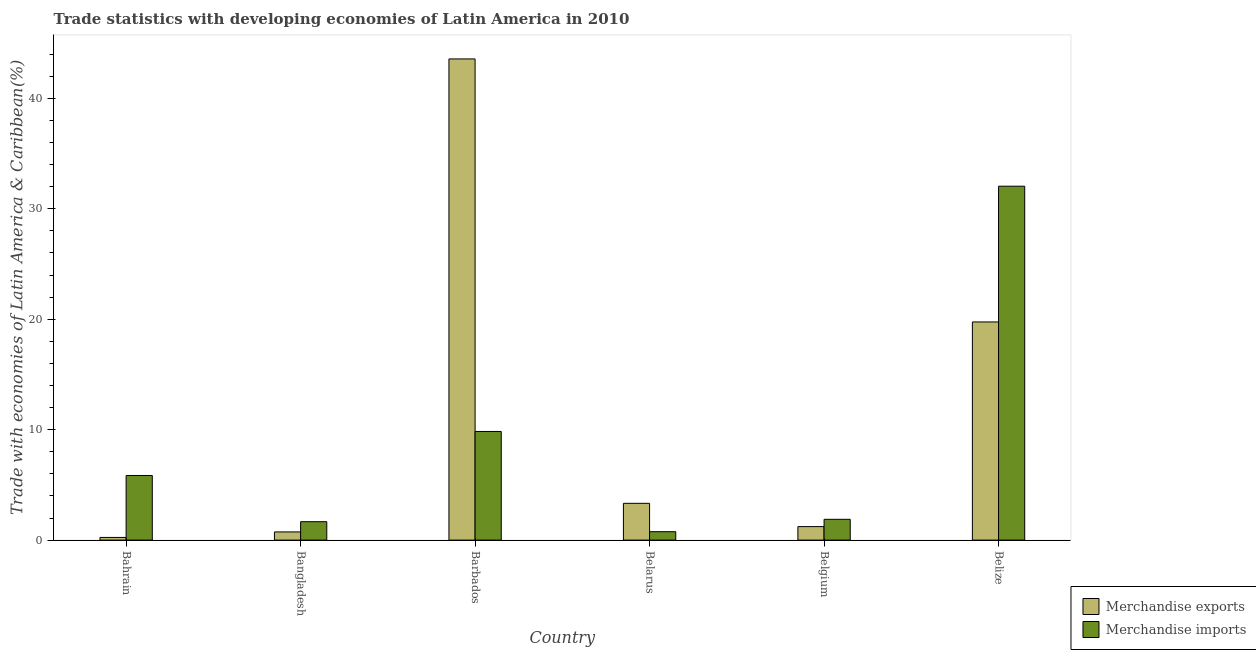Are the number of bars per tick equal to the number of legend labels?
Provide a succinct answer. Yes. How many bars are there on the 1st tick from the left?
Provide a short and direct response. 2. What is the label of the 1st group of bars from the left?
Give a very brief answer. Bahrain. In how many cases, is the number of bars for a given country not equal to the number of legend labels?
Offer a very short reply. 0. What is the merchandise exports in Belize?
Make the answer very short. 19.75. Across all countries, what is the maximum merchandise imports?
Make the answer very short. 32.05. Across all countries, what is the minimum merchandise imports?
Provide a succinct answer. 0.76. In which country was the merchandise exports maximum?
Provide a short and direct response. Barbados. In which country was the merchandise exports minimum?
Your response must be concise. Bahrain. What is the total merchandise imports in the graph?
Your response must be concise. 52.04. What is the difference between the merchandise imports in Bangladesh and that in Belize?
Keep it short and to the point. -30.38. What is the difference between the merchandise exports in Belgium and the merchandise imports in Barbados?
Offer a very short reply. -8.61. What is the average merchandise imports per country?
Your answer should be very brief. 8.67. What is the difference between the merchandise imports and merchandise exports in Belarus?
Your response must be concise. -2.57. What is the ratio of the merchandise exports in Bangladesh to that in Belarus?
Your response must be concise. 0.22. What is the difference between the highest and the second highest merchandise exports?
Offer a terse response. 23.82. What is the difference between the highest and the lowest merchandise imports?
Provide a short and direct response. 31.28. Is the sum of the merchandise exports in Belarus and Belize greater than the maximum merchandise imports across all countries?
Provide a short and direct response. No. What does the 1st bar from the left in Bangladesh represents?
Your answer should be compact. Merchandise exports. What does the 1st bar from the right in Barbados represents?
Your answer should be very brief. Merchandise imports. Are the values on the major ticks of Y-axis written in scientific E-notation?
Your response must be concise. No. Does the graph contain any zero values?
Give a very brief answer. No. How many legend labels are there?
Ensure brevity in your answer.  2. What is the title of the graph?
Provide a short and direct response. Trade statistics with developing economies of Latin America in 2010. Does "Exports" appear as one of the legend labels in the graph?
Your answer should be compact. No. What is the label or title of the Y-axis?
Ensure brevity in your answer.  Trade with economies of Latin America & Caribbean(%). What is the Trade with economies of Latin America & Caribbean(%) of Merchandise exports in Bahrain?
Offer a very short reply. 0.24. What is the Trade with economies of Latin America & Caribbean(%) in Merchandise imports in Bahrain?
Make the answer very short. 5.85. What is the Trade with economies of Latin America & Caribbean(%) of Merchandise exports in Bangladesh?
Keep it short and to the point. 0.74. What is the Trade with economies of Latin America & Caribbean(%) of Merchandise imports in Bangladesh?
Offer a terse response. 1.67. What is the Trade with economies of Latin America & Caribbean(%) of Merchandise exports in Barbados?
Offer a terse response. 43.57. What is the Trade with economies of Latin America & Caribbean(%) of Merchandise imports in Barbados?
Keep it short and to the point. 9.84. What is the Trade with economies of Latin America & Caribbean(%) in Merchandise exports in Belarus?
Provide a short and direct response. 3.33. What is the Trade with economies of Latin America & Caribbean(%) of Merchandise imports in Belarus?
Offer a very short reply. 0.76. What is the Trade with economies of Latin America & Caribbean(%) of Merchandise exports in Belgium?
Give a very brief answer. 1.22. What is the Trade with economies of Latin America & Caribbean(%) of Merchandise imports in Belgium?
Make the answer very short. 1.88. What is the Trade with economies of Latin America & Caribbean(%) of Merchandise exports in Belize?
Give a very brief answer. 19.75. What is the Trade with economies of Latin America & Caribbean(%) of Merchandise imports in Belize?
Offer a terse response. 32.05. Across all countries, what is the maximum Trade with economies of Latin America & Caribbean(%) in Merchandise exports?
Make the answer very short. 43.57. Across all countries, what is the maximum Trade with economies of Latin America & Caribbean(%) of Merchandise imports?
Ensure brevity in your answer.  32.05. Across all countries, what is the minimum Trade with economies of Latin America & Caribbean(%) in Merchandise exports?
Keep it short and to the point. 0.24. Across all countries, what is the minimum Trade with economies of Latin America & Caribbean(%) of Merchandise imports?
Keep it short and to the point. 0.76. What is the total Trade with economies of Latin America & Caribbean(%) of Merchandise exports in the graph?
Your answer should be very brief. 68.86. What is the total Trade with economies of Latin America & Caribbean(%) of Merchandise imports in the graph?
Your answer should be compact. 52.04. What is the difference between the Trade with economies of Latin America & Caribbean(%) of Merchandise exports in Bahrain and that in Bangladesh?
Ensure brevity in your answer.  -0.5. What is the difference between the Trade with economies of Latin America & Caribbean(%) of Merchandise imports in Bahrain and that in Bangladesh?
Ensure brevity in your answer.  4.18. What is the difference between the Trade with economies of Latin America & Caribbean(%) of Merchandise exports in Bahrain and that in Barbados?
Offer a very short reply. -43.33. What is the difference between the Trade with economies of Latin America & Caribbean(%) in Merchandise imports in Bahrain and that in Barbados?
Your answer should be very brief. -3.99. What is the difference between the Trade with economies of Latin America & Caribbean(%) in Merchandise exports in Bahrain and that in Belarus?
Provide a short and direct response. -3.09. What is the difference between the Trade with economies of Latin America & Caribbean(%) in Merchandise imports in Bahrain and that in Belarus?
Your response must be concise. 5.09. What is the difference between the Trade with economies of Latin America & Caribbean(%) of Merchandise exports in Bahrain and that in Belgium?
Offer a very short reply. -0.98. What is the difference between the Trade with economies of Latin America & Caribbean(%) of Merchandise imports in Bahrain and that in Belgium?
Your answer should be very brief. 3.97. What is the difference between the Trade with economies of Latin America & Caribbean(%) in Merchandise exports in Bahrain and that in Belize?
Your response must be concise. -19.51. What is the difference between the Trade with economies of Latin America & Caribbean(%) in Merchandise imports in Bahrain and that in Belize?
Provide a succinct answer. -26.19. What is the difference between the Trade with economies of Latin America & Caribbean(%) of Merchandise exports in Bangladesh and that in Barbados?
Your answer should be compact. -42.83. What is the difference between the Trade with economies of Latin America & Caribbean(%) in Merchandise imports in Bangladesh and that in Barbados?
Offer a terse response. -8.17. What is the difference between the Trade with economies of Latin America & Caribbean(%) of Merchandise exports in Bangladesh and that in Belarus?
Provide a succinct answer. -2.59. What is the difference between the Trade with economies of Latin America & Caribbean(%) of Merchandise imports in Bangladesh and that in Belarus?
Your answer should be compact. 0.9. What is the difference between the Trade with economies of Latin America & Caribbean(%) of Merchandise exports in Bangladesh and that in Belgium?
Make the answer very short. -0.48. What is the difference between the Trade with economies of Latin America & Caribbean(%) of Merchandise imports in Bangladesh and that in Belgium?
Provide a succinct answer. -0.22. What is the difference between the Trade with economies of Latin America & Caribbean(%) of Merchandise exports in Bangladesh and that in Belize?
Ensure brevity in your answer.  -19.01. What is the difference between the Trade with economies of Latin America & Caribbean(%) in Merchandise imports in Bangladesh and that in Belize?
Keep it short and to the point. -30.38. What is the difference between the Trade with economies of Latin America & Caribbean(%) in Merchandise exports in Barbados and that in Belarus?
Ensure brevity in your answer.  40.24. What is the difference between the Trade with economies of Latin America & Caribbean(%) in Merchandise imports in Barbados and that in Belarus?
Make the answer very short. 9.08. What is the difference between the Trade with economies of Latin America & Caribbean(%) in Merchandise exports in Barbados and that in Belgium?
Offer a terse response. 42.35. What is the difference between the Trade with economies of Latin America & Caribbean(%) in Merchandise imports in Barbados and that in Belgium?
Keep it short and to the point. 7.95. What is the difference between the Trade with economies of Latin America & Caribbean(%) of Merchandise exports in Barbados and that in Belize?
Provide a succinct answer. 23.82. What is the difference between the Trade with economies of Latin America & Caribbean(%) in Merchandise imports in Barbados and that in Belize?
Give a very brief answer. -22.21. What is the difference between the Trade with economies of Latin America & Caribbean(%) of Merchandise exports in Belarus and that in Belgium?
Provide a short and direct response. 2.11. What is the difference between the Trade with economies of Latin America & Caribbean(%) of Merchandise imports in Belarus and that in Belgium?
Provide a short and direct response. -1.12. What is the difference between the Trade with economies of Latin America & Caribbean(%) of Merchandise exports in Belarus and that in Belize?
Make the answer very short. -16.42. What is the difference between the Trade with economies of Latin America & Caribbean(%) in Merchandise imports in Belarus and that in Belize?
Ensure brevity in your answer.  -31.28. What is the difference between the Trade with economies of Latin America & Caribbean(%) of Merchandise exports in Belgium and that in Belize?
Provide a short and direct response. -18.53. What is the difference between the Trade with economies of Latin America & Caribbean(%) in Merchandise imports in Belgium and that in Belize?
Your answer should be compact. -30.16. What is the difference between the Trade with economies of Latin America & Caribbean(%) of Merchandise exports in Bahrain and the Trade with economies of Latin America & Caribbean(%) of Merchandise imports in Bangladesh?
Provide a short and direct response. -1.42. What is the difference between the Trade with economies of Latin America & Caribbean(%) of Merchandise exports in Bahrain and the Trade with economies of Latin America & Caribbean(%) of Merchandise imports in Barbados?
Provide a short and direct response. -9.6. What is the difference between the Trade with economies of Latin America & Caribbean(%) in Merchandise exports in Bahrain and the Trade with economies of Latin America & Caribbean(%) in Merchandise imports in Belarus?
Offer a terse response. -0.52. What is the difference between the Trade with economies of Latin America & Caribbean(%) of Merchandise exports in Bahrain and the Trade with economies of Latin America & Caribbean(%) of Merchandise imports in Belgium?
Offer a very short reply. -1.64. What is the difference between the Trade with economies of Latin America & Caribbean(%) in Merchandise exports in Bahrain and the Trade with economies of Latin America & Caribbean(%) in Merchandise imports in Belize?
Your response must be concise. -31.8. What is the difference between the Trade with economies of Latin America & Caribbean(%) of Merchandise exports in Bangladesh and the Trade with economies of Latin America & Caribbean(%) of Merchandise imports in Barbados?
Offer a very short reply. -9.1. What is the difference between the Trade with economies of Latin America & Caribbean(%) of Merchandise exports in Bangladesh and the Trade with economies of Latin America & Caribbean(%) of Merchandise imports in Belarus?
Offer a very short reply. -0.02. What is the difference between the Trade with economies of Latin America & Caribbean(%) in Merchandise exports in Bangladesh and the Trade with economies of Latin America & Caribbean(%) in Merchandise imports in Belgium?
Make the answer very short. -1.14. What is the difference between the Trade with economies of Latin America & Caribbean(%) in Merchandise exports in Bangladesh and the Trade with economies of Latin America & Caribbean(%) in Merchandise imports in Belize?
Keep it short and to the point. -31.31. What is the difference between the Trade with economies of Latin America & Caribbean(%) of Merchandise exports in Barbados and the Trade with economies of Latin America & Caribbean(%) of Merchandise imports in Belarus?
Your answer should be compact. 42.81. What is the difference between the Trade with economies of Latin America & Caribbean(%) of Merchandise exports in Barbados and the Trade with economies of Latin America & Caribbean(%) of Merchandise imports in Belgium?
Your answer should be compact. 41.69. What is the difference between the Trade with economies of Latin America & Caribbean(%) of Merchandise exports in Barbados and the Trade with economies of Latin America & Caribbean(%) of Merchandise imports in Belize?
Your answer should be compact. 11.52. What is the difference between the Trade with economies of Latin America & Caribbean(%) in Merchandise exports in Belarus and the Trade with economies of Latin America & Caribbean(%) in Merchandise imports in Belgium?
Your answer should be very brief. 1.45. What is the difference between the Trade with economies of Latin America & Caribbean(%) in Merchandise exports in Belarus and the Trade with economies of Latin America & Caribbean(%) in Merchandise imports in Belize?
Offer a very short reply. -28.71. What is the difference between the Trade with economies of Latin America & Caribbean(%) of Merchandise exports in Belgium and the Trade with economies of Latin America & Caribbean(%) of Merchandise imports in Belize?
Give a very brief answer. -30.82. What is the average Trade with economies of Latin America & Caribbean(%) of Merchandise exports per country?
Offer a terse response. 11.48. What is the average Trade with economies of Latin America & Caribbean(%) in Merchandise imports per country?
Your answer should be very brief. 8.67. What is the difference between the Trade with economies of Latin America & Caribbean(%) in Merchandise exports and Trade with economies of Latin America & Caribbean(%) in Merchandise imports in Bahrain?
Keep it short and to the point. -5.61. What is the difference between the Trade with economies of Latin America & Caribbean(%) in Merchandise exports and Trade with economies of Latin America & Caribbean(%) in Merchandise imports in Bangladesh?
Ensure brevity in your answer.  -0.93. What is the difference between the Trade with economies of Latin America & Caribbean(%) of Merchandise exports and Trade with economies of Latin America & Caribbean(%) of Merchandise imports in Barbados?
Keep it short and to the point. 33.73. What is the difference between the Trade with economies of Latin America & Caribbean(%) in Merchandise exports and Trade with economies of Latin America & Caribbean(%) in Merchandise imports in Belarus?
Your response must be concise. 2.57. What is the difference between the Trade with economies of Latin America & Caribbean(%) in Merchandise exports and Trade with economies of Latin America & Caribbean(%) in Merchandise imports in Belgium?
Ensure brevity in your answer.  -0.66. What is the difference between the Trade with economies of Latin America & Caribbean(%) of Merchandise exports and Trade with economies of Latin America & Caribbean(%) of Merchandise imports in Belize?
Your response must be concise. -12.29. What is the ratio of the Trade with economies of Latin America & Caribbean(%) in Merchandise exports in Bahrain to that in Bangladesh?
Offer a terse response. 0.33. What is the ratio of the Trade with economies of Latin America & Caribbean(%) of Merchandise imports in Bahrain to that in Bangladesh?
Make the answer very short. 3.51. What is the ratio of the Trade with economies of Latin America & Caribbean(%) in Merchandise exports in Bahrain to that in Barbados?
Provide a short and direct response. 0.01. What is the ratio of the Trade with economies of Latin America & Caribbean(%) of Merchandise imports in Bahrain to that in Barbados?
Provide a short and direct response. 0.59. What is the ratio of the Trade with economies of Latin America & Caribbean(%) in Merchandise exports in Bahrain to that in Belarus?
Your response must be concise. 0.07. What is the ratio of the Trade with economies of Latin America & Caribbean(%) in Merchandise imports in Bahrain to that in Belarus?
Your answer should be compact. 7.68. What is the ratio of the Trade with economies of Latin America & Caribbean(%) of Merchandise exports in Bahrain to that in Belgium?
Your response must be concise. 0.2. What is the ratio of the Trade with economies of Latin America & Caribbean(%) of Merchandise imports in Bahrain to that in Belgium?
Offer a terse response. 3.11. What is the ratio of the Trade with economies of Latin America & Caribbean(%) in Merchandise exports in Bahrain to that in Belize?
Ensure brevity in your answer.  0.01. What is the ratio of the Trade with economies of Latin America & Caribbean(%) of Merchandise imports in Bahrain to that in Belize?
Provide a short and direct response. 0.18. What is the ratio of the Trade with economies of Latin America & Caribbean(%) of Merchandise exports in Bangladesh to that in Barbados?
Ensure brevity in your answer.  0.02. What is the ratio of the Trade with economies of Latin America & Caribbean(%) of Merchandise imports in Bangladesh to that in Barbados?
Offer a very short reply. 0.17. What is the ratio of the Trade with economies of Latin America & Caribbean(%) in Merchandise exports in Bangladesh to that in Belarus?
Ensure brevity in your answer.  0.22. What is the ratio of the Trade with economies of Latin America & Caribbean(%) in Merchandise imports in Bangladesh to that in Belarus?
Give a very brief answer. 2.19. What is the ratio of the Trade with economies of Latin America & Caribbean(%) in Merchandise exports in Bangladesh to that in Belgium?
Your answer should be very brief. 0.61. What is the ratio of the Trade with economies of Latin America & Caribbean(%) of Merchandise imports in Bangladesh to that in Belgium?
Your answer should be compact. 0.89. What is the ratio of the Trade with economies of Latin America & Caribbean(%) of Merchandise exports in Bangladesh to that in Belize?
Keep it short and to the point. 0.04. What is the ratio of the Trade with economies of Latin America & Caribbean(%) of Merchandise imports in Bangladesh to that in Belize?
Provide a succinct answer. 0.05. What is the ratio of the Trade with economies of Latin America & Caribbean(%) in Merchandise exports in Barbados to that in Belarus?
Ensure brevity in your answer.  13.08. What is the ratio of the Trade with economies of Latin America & Caribbean(%) in Merchandise imports in Barbados to that in Belarus?
Your answer should be very brief. 12.91. What is the ratio of the Trade with economies of Latin America & Caribbean(%) in Merchandise exports in Barbados to that in Belgium?
Give a very brief answer. 35.65. What is the ratio of the Trade with economies of Latin America & Caribbean(%) of Merchandise imports in Barbados to that in Belgium?
Ensure brevity in your answer.  5.23. What is the ratio of the Trade with economies of Latin America & Caribbean(%) in Merchandise exports in Barbados to that in Belize?
Provide a succinct answer. 2.21. What is the ratio of the Trade with economies of Latin America & Caribbean(%) of Merchandise imports in Barbados to that in Belize?
Your answer should be very brief. 0.31. What is the ratio of the Trade with economies of Latin America & Caribbean(%) in Merchandise exports in Belarus to that in Belgium?
Keep it short and to the point. 2.73. What is the ratio of the Trade with economies of Latin America & Caribbean(%) of Merchandise imports in Belarus to that in Belgium?
Provide a succinct answer. 0.4. What is the ratio of the Trade with economies of Latin America & Caribbean(%) of Merchandise exports in Belarus to that in Belize?
Ensure brevity in your answer.  0.17. What is the ratio of the Trade with economies of Latin America & Caribbean(%) of Merchandise imports in Belarus to that in Belize?
Give a very brief answer. 0.02. What is the ratio of the Trade with economies of Latin America & Caribbean(%) in Merchandise exports in Belgium to that in Belize?
Offer a very short reply. 0.06. What is the ratio of the Trade with economies of Latin America & Caribbean(%) of Merchandise imports in Belgium to that in Belize?
Keep it short and to the point. 0.06. What is the difference between the highest and the second highest Trade with economies of Latin America & Caribbean(%) in Merchandise exports?
Your response must be concise. 23.82. What is the difference between the highest and the second highest Trade with economies of Latin America & Caribbean(%) of Merchandise imports?
Your response must be concise. 22.21. What is the difference between the highest and the lowest Trade with economies of Latin America & Caribbean(%) of Merchandise exports?
Keep it short and to the point. 43.33. What is the difference between the highest and the lowest Trade with economies of Latin America & Caribbean(%) of Merchandise imports?
Your response must be concise. 31.28. 